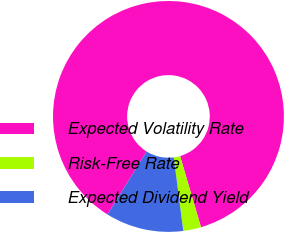<chart> <loc_0><loc_0><loc_500><loc_500><pie_chart><fcel>Expected Volatility Rate<fcel>Risk-Free Rate<fcel>Expected Dividend Yield<nl><fcel>86.59%<fcel>2.5%<fcel>10.91%<nl></chart> 